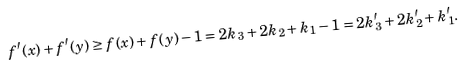<formula> <loc_0><loc_0><loc_500><loc_500>f ^ { \prime } ( x ) + f ^ { \prime } ( y ) \geq f ( x ) + f ( y ) - 1 = 2 k _ { 3 } + 2 k _ { 2 } + k _ { 1 } - 1 = 2 k _ { 3 } ^ { \prime } + 2 k ^ { \prime } _ { 2 } + k _ { 1 } ^ { \prime } .</formula> 